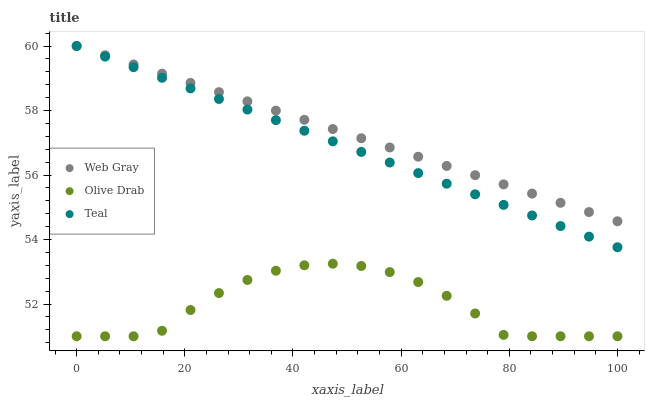Does Olive Drab have the minimum area under the curve?
Answer yes or no. Yes. Does Web Gray have the maximum area under the curve?
Answer yes or no. Yes. Does Teal have the minimum area under the curve?
Answer yes or no. No. Does Teal have the maximum area under the curve?
Answer yes or no. No. Is Teal the smoothest?
Answer yes or no. Yes. Is Olive Drab the roughest?
Answer yes or no. Yes. Is Olive Drab the smoothest?
Answer yes or no. No. Is Teal the roughest?
Answer yes or no. No. Does Olive Drab have the lowest value?
Answer yes or no. Yes. Does Teal have the lowest value?
Answer yes or no. No. Does Teal have the highest value?
Answer yes or no. Yes. Does Olive Drab have the highest value?
Answer yes or no. No. Is Olive Drab less than Web Gray?
Answer yes or no. Yes. Is Teal greater than Olive Drab?
Answer yes or no. Yes. Does Teal intersect Web Gray?
Answer yes or no. Yes. Is Teal less than Web Gray?
Answer yes or no. No. Is Teal greater than Web Gray?
Answer yes or no. No. Does Olive Drab intersect Web Gray?
Answer yes or no. No. 